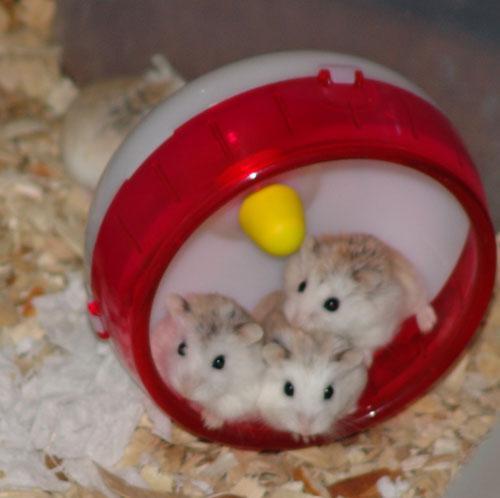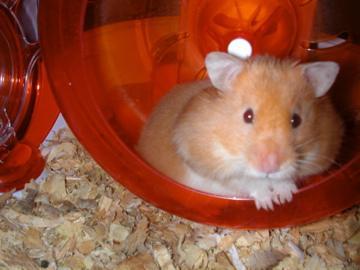The first image is the image on the left, the second image is the image on the right. Examine the images to the left and right. Is the description "The left image contains a rodent running on a blue hamster wheel." accurate? Answer yes or no. No. The first image is the image on the left, the second image is the image on the right. For the images displayed, is the sentence "Each image features at least one pet rodent in a wheel, and the wheel on the left is blue while the one on the right is red." factually correct? Answer yes or no. No. 